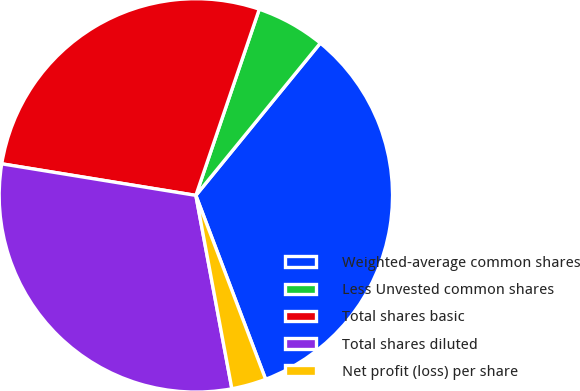Convert chart. <chart><loc_0><loc_0><loc_500><loc_500><pie_chart><fcel>Weighted-average common shares<fcel>Less Unvested common shares<fcel>Total shares basic<fcel>Total shares diluted<fcel>Net profit (loss) per share<nl><fcel>33.33%<fcel>5.68%<fcel>27.66%<fcel>30.5%<fcel>2.84%<nl></chart> 